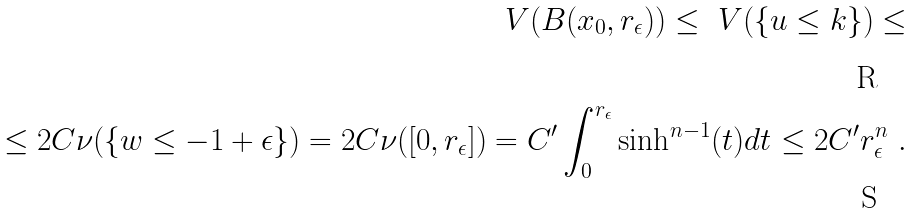Convert formula to latex. <formula><loc_0><loc_0><loc_500><loc_500>\ V ( B ( x _ { 0 } , r _ { \epsilon } ) ) \leq \ V ( \{ u \leq k \} ) \leq \\ \leq 2 C \nu ( \{ w \leq - 1 + \epsilon \} ) = 2 C \nu ( [ 0 , r _ { \epsilon } ] ) = C ^ { \prime } \int _ { 0 } ^ { r _ { \epsilon } } \sinh ^ { n - 1 } ( t ) d t \leq 2 C ^ { \prime } r _ { \epsilon } ^ { n } \ .</formula> 